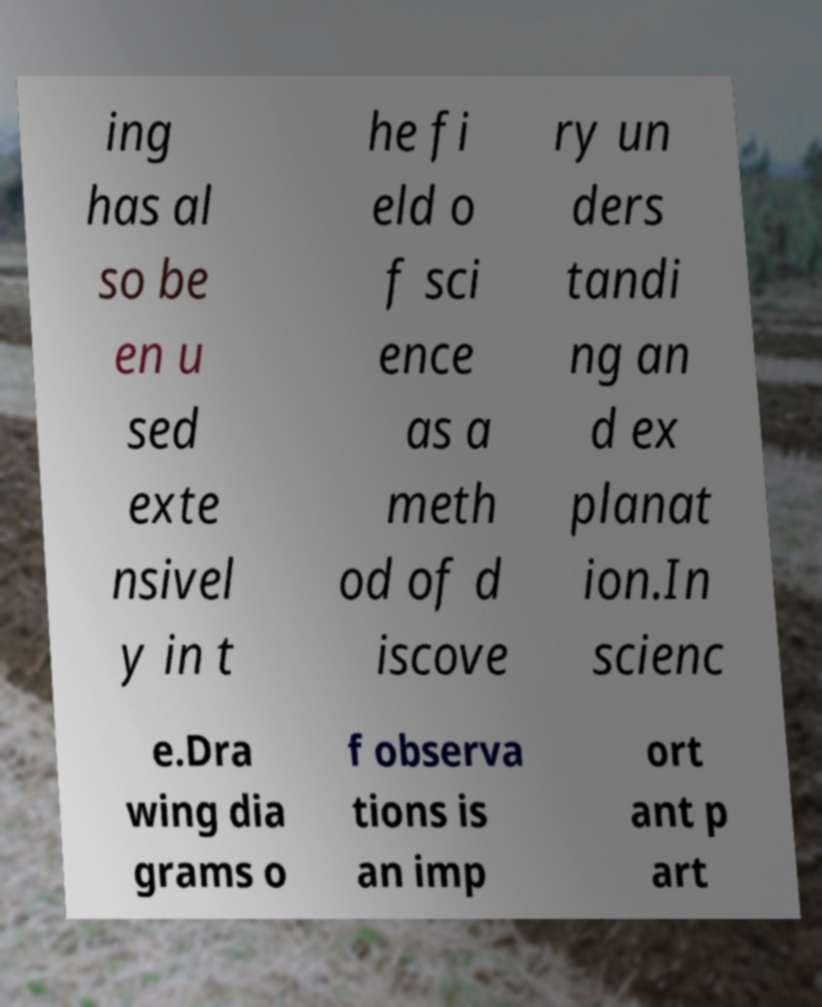Please identify and transcribe the text found in this image. ing has al so be en u sed exte nsivel y in t he fi eld o f sci ence as a meth od of d iscove ry un ders tandi ng an d ex planat ion.In scienc e.Dra wing dia grams o f observa tions is an imp ort ant p art 